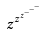<formula> <loc_0><loc_0><loc_500><loc_500>z ^ { z ^ { z ^ { - ^ { - ^ { - } } } } }</formula> 